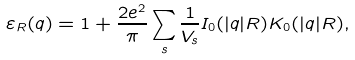Convert formula to latex. <formula><loc_0><loc_0><loc_500><loc_500>\varepsilon _ { R } ( q ) = 1 + \frac { 2 e ^ { 2 } } { \pi } \sum _ { s } \frac { 1 } { V _ { s } } I _ { 0 } ( | q | R ) K _ { 0 } ( | q | R ) ,</formula> 